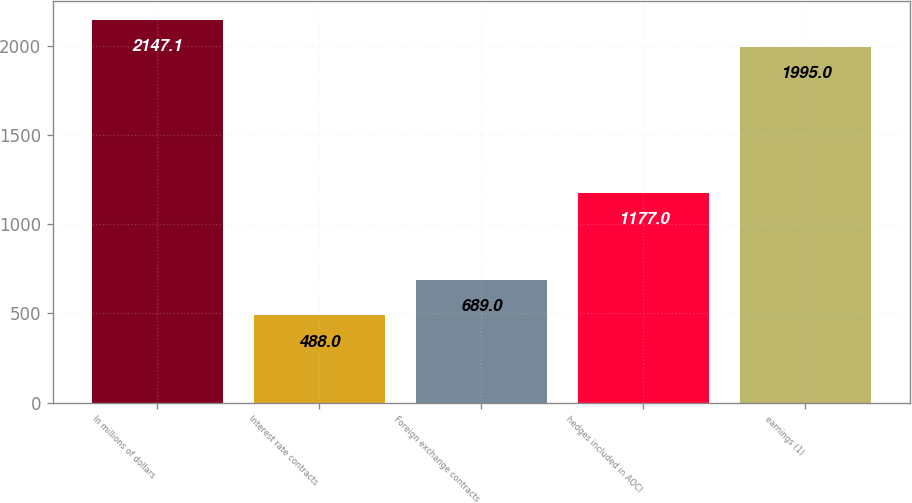<chart> <loc_0><loc_0><loc_500><loc_500><bar_chart><fcel>In millions of dollars<fcel>Interest rate contracts<fcel>Foreign exchange contracts<fcel>hedges included in AOCI<fcel>earnings (1)<nl><fcel>2147.1<fcel>488<fcel>689<fcel>1177<fcel>1995<nl></chart> 